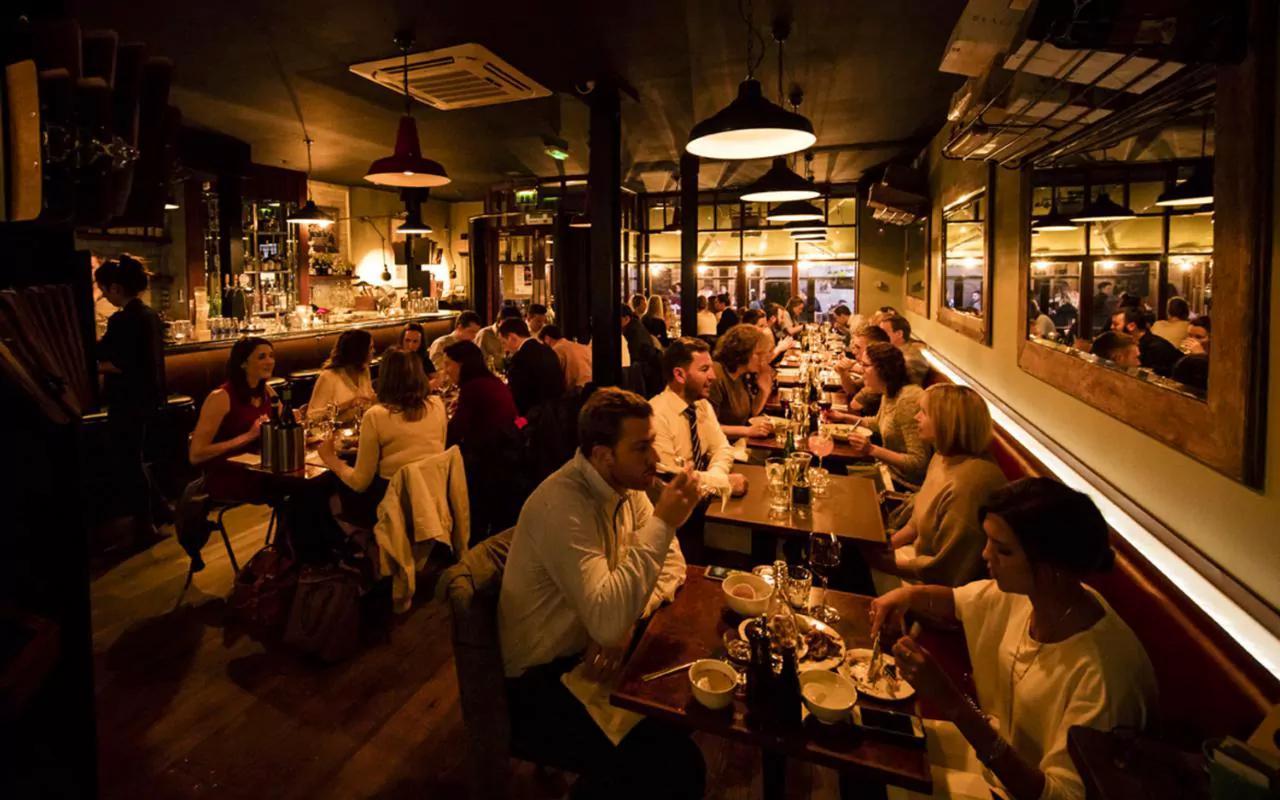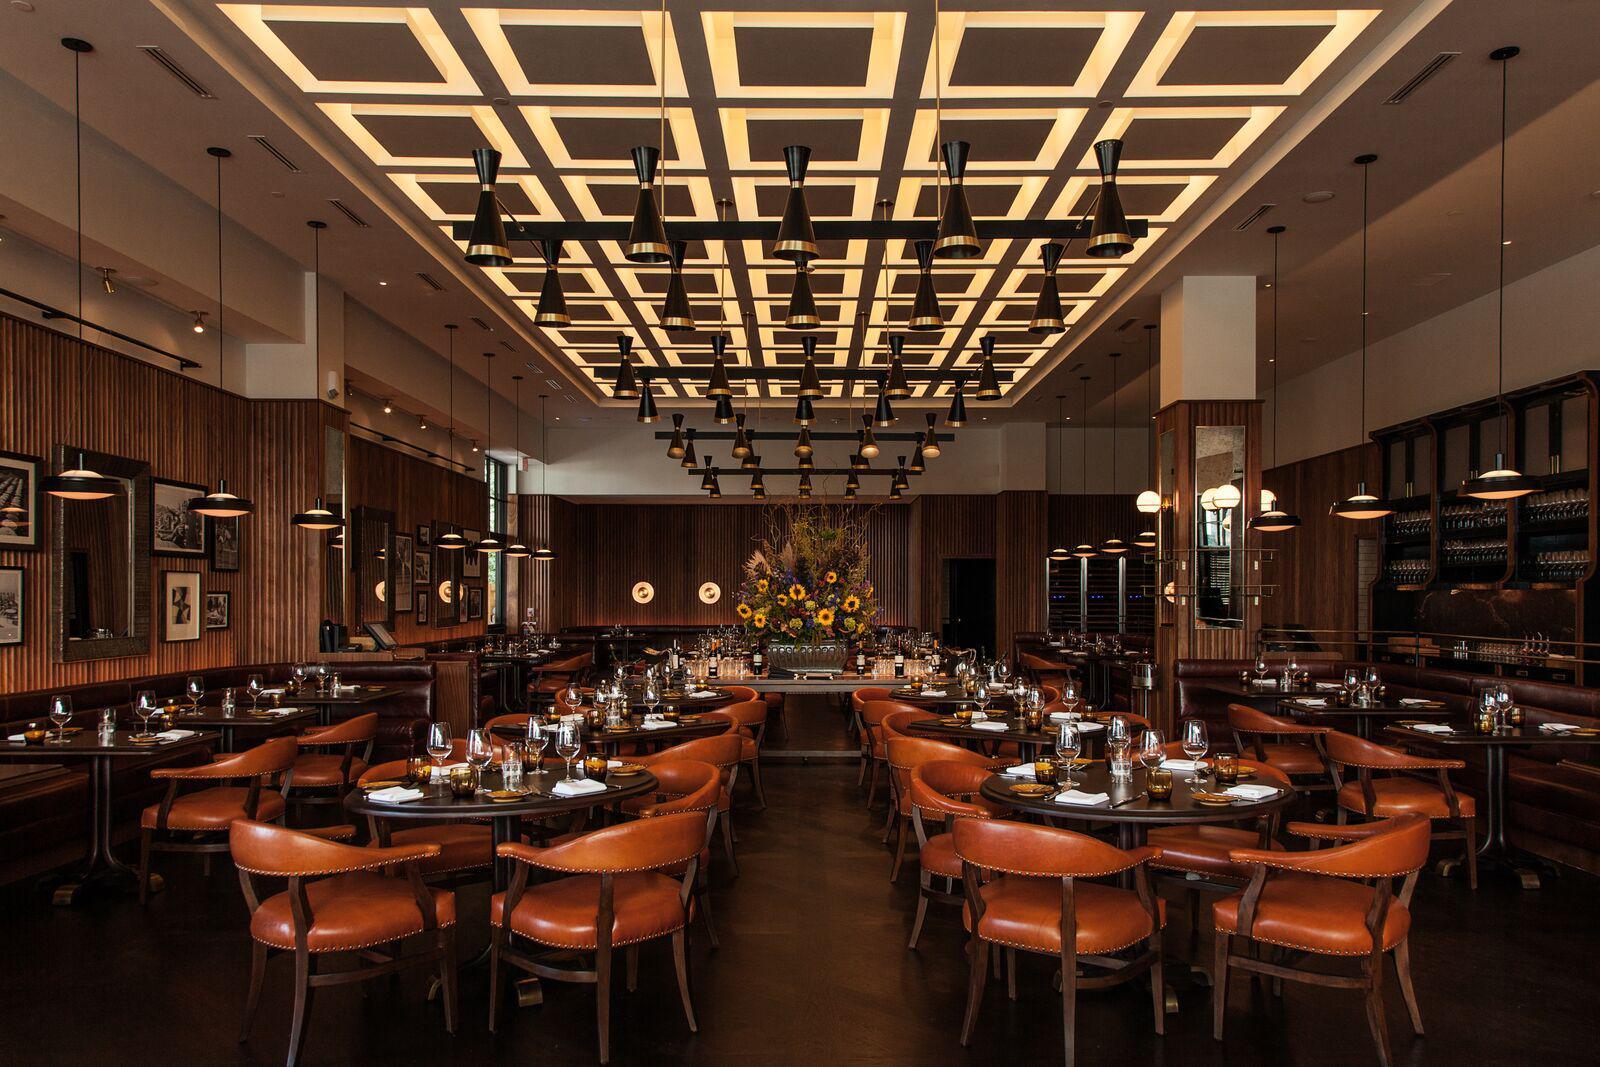The first image is the image on the left, the second image is the image on the right. Analyze the images presented: Is the assertion "In the right image, there's an empty restaurant." valid? Answer yes or no. Yes. The first image is the image on the left, the second image is the image on the right. For the images shown, is this caption "In the left image, light fixtures with round bottoms suspend over a row of tables with windows to their right, and the restaurant is packed with customers." true? Answer yes or no. Yes. 